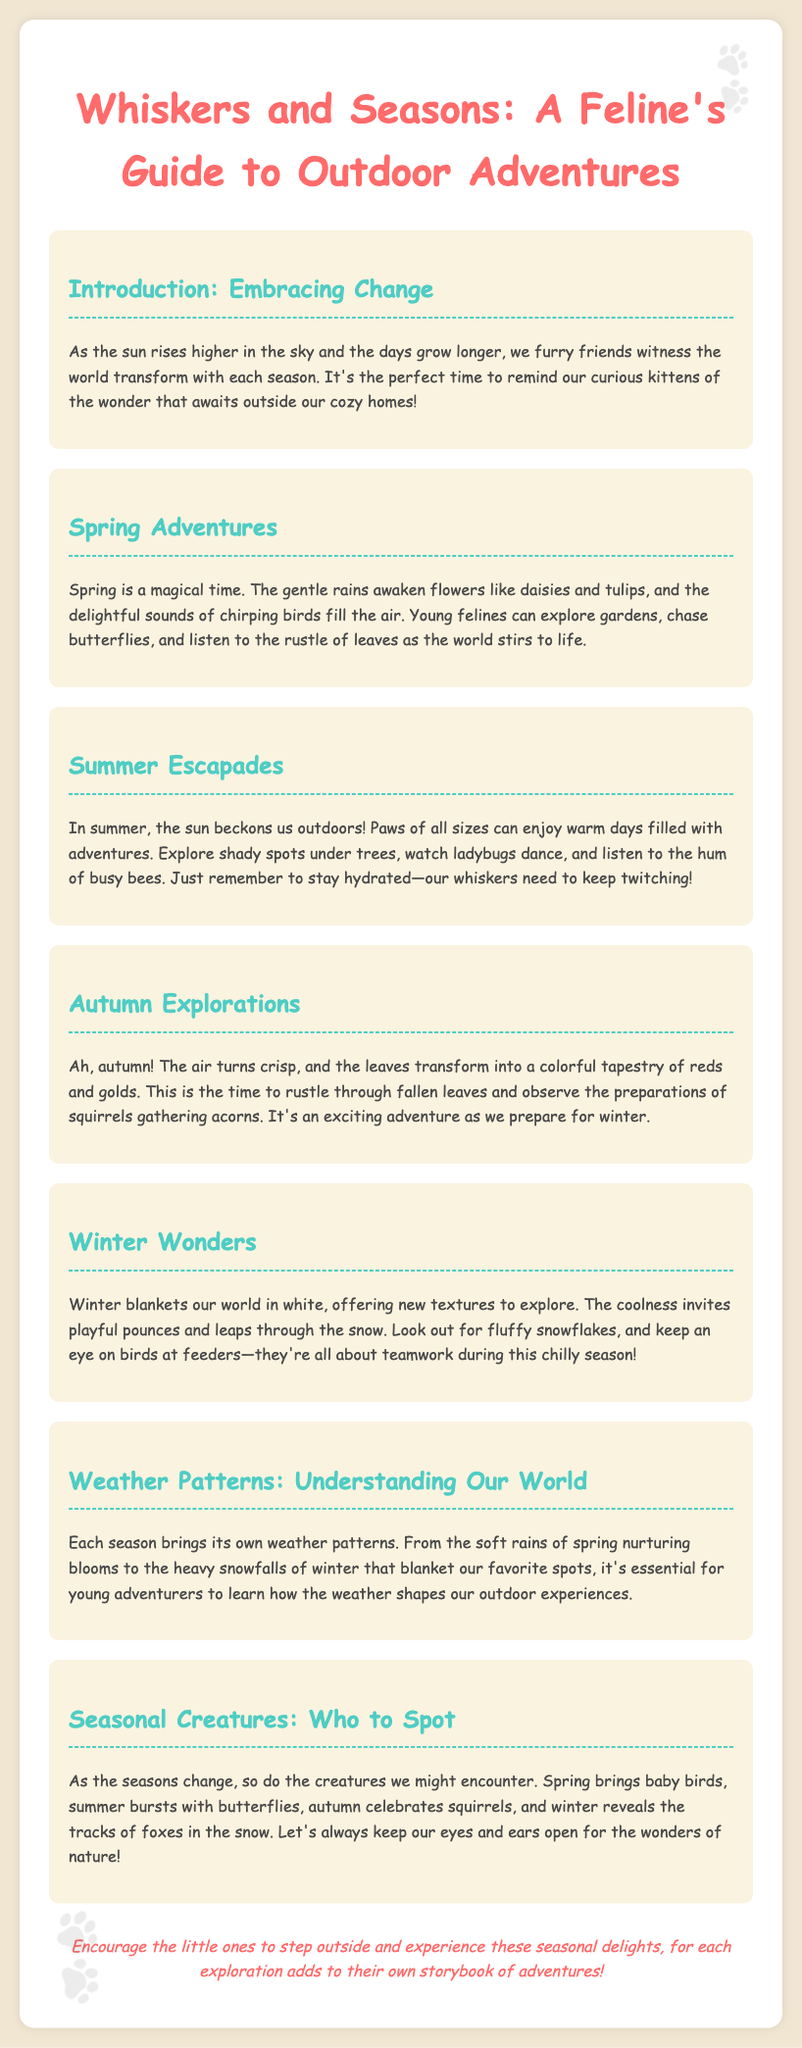What is the title of the newsletter? The title of the newsletter is presented in the header of the document, which is "Whiskers and Seasons: A Feline's Guide to Outdoor Adventures."
Answer: Whiskers and Seasons: A Feline's Guide to Outdoor Adventures How many main sections are in the newsletter? The number of main sections can be counted from the document; there are seven sections including the introduction.
Answer: 7 What season is associated with the transformation of leaves into red and gold? The document specifically mentions autumn as the season when leaves change to red and gold.
Answer: Autumn What creature is celebrated in summer? The document mentions butterflies as the prominent creature during summer.
Answer: Butterflies What type of weather pattern is associated with winter in the newsletter? The newsletter describes heavy snowfalls as a key weather pattern during winter.
Answer: Heavy snowfalls What comforting phrase is found in the closing remark? The closing remark encourages young adventurers to experience seasonal delights, which is found in the last paragraph.
Answer: Step outside and experience these seasonal delights In which section would you find information about the seasons' impact on outdoor experiences? The section titled "Weather Patterns: Understanding Our World" discusses how seasons influence outdoor experiences.
Answer: Weather Patterns: Understanding Our World 